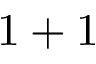Convert formula to latex. <formula><loc_0><loc_0><loc_500><loc_500>1 + 1</formula> 